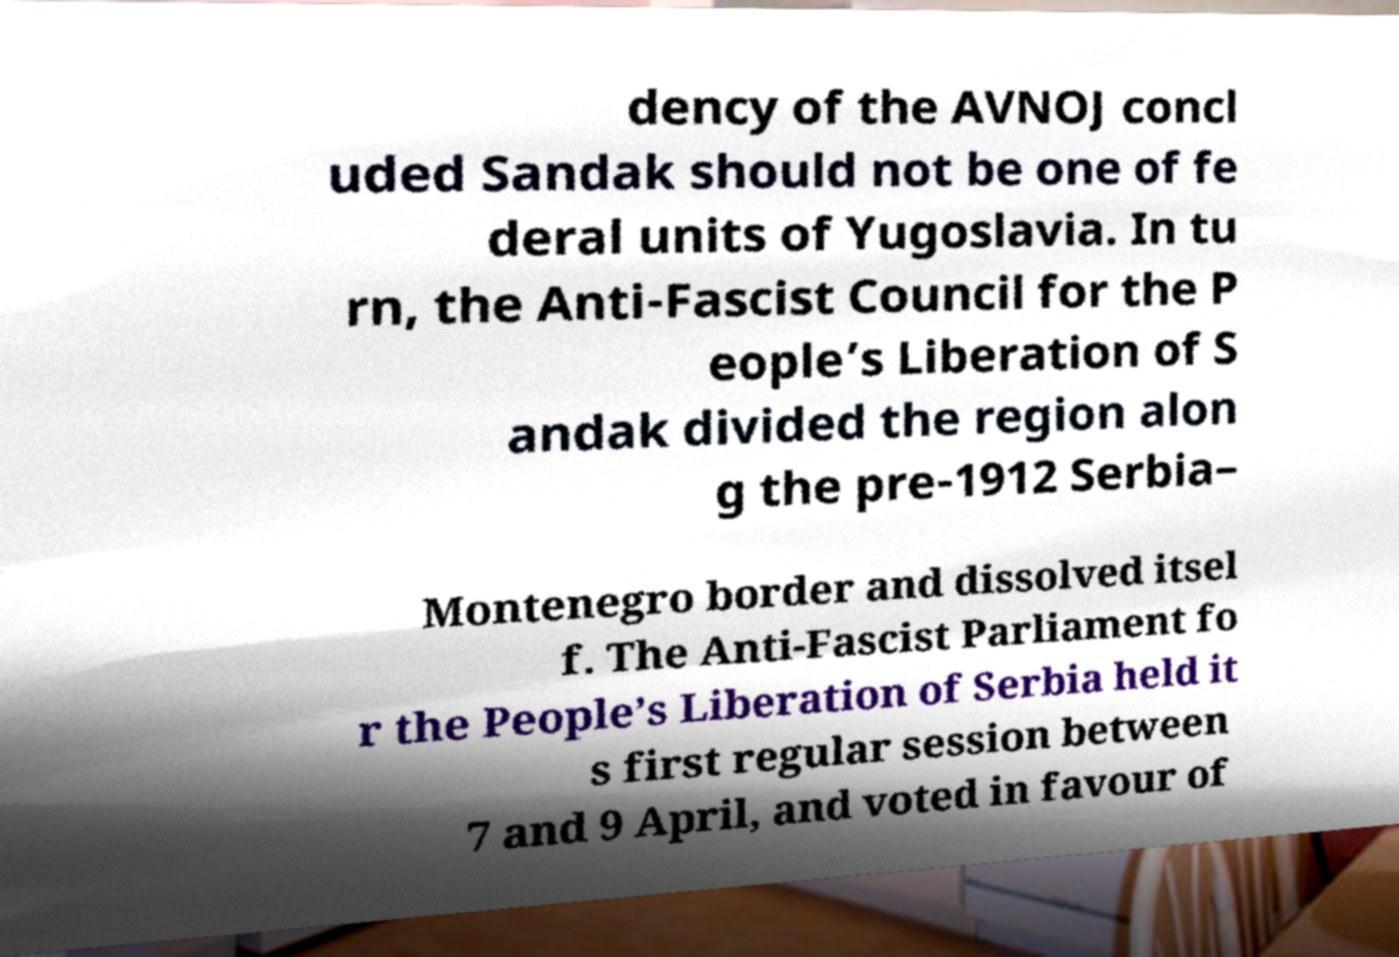Can you accurately transcribe the text from the provided image for me? dency of the AVNOJ concl uded Sandak should not be one of fe deral units of Yugoslavia. In tu rn, the Anti-Fascist Council for the P eople’s Liberation of S andak divided the region alon g the pre-1912 Serbia– Montenegro border and dissolved itsel f. The Anti-Fascist Parliament fo r the People’s Liberation of Serbia held it s first regular session between 7 and 9 April, and voted in favour of 